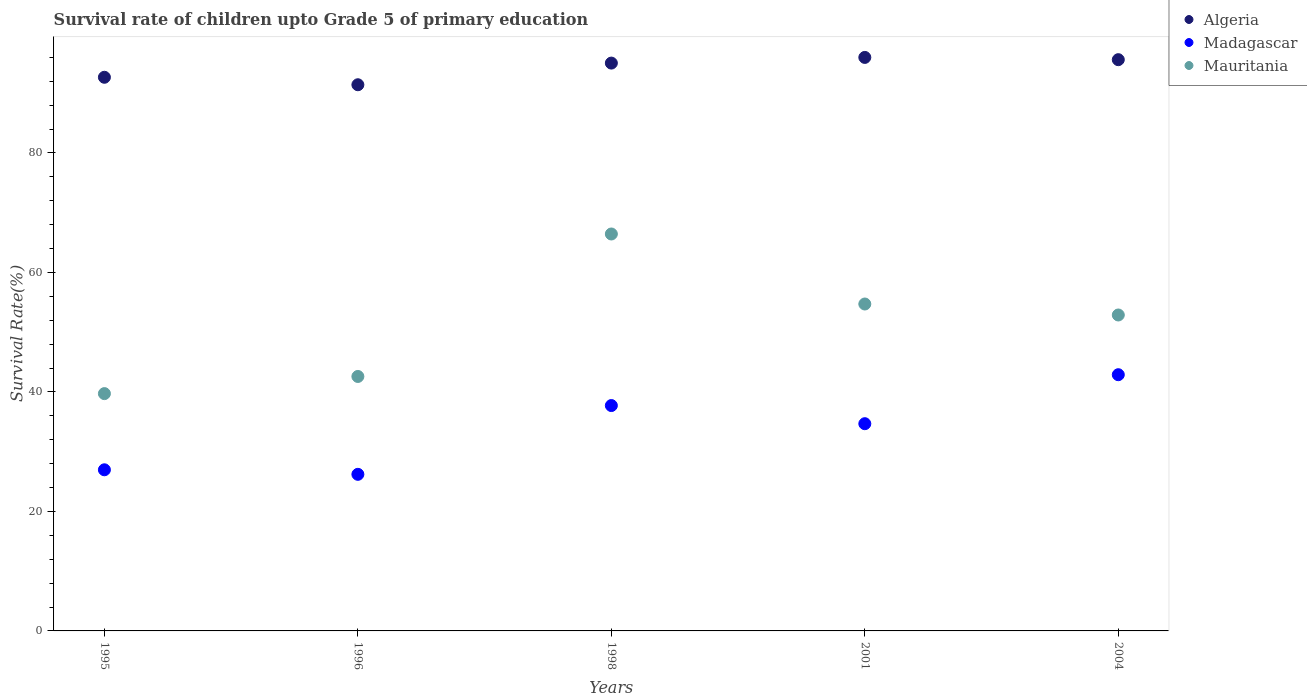What is the survival rate of children in Madagascar in 1995?
Give a very brief answer. 26.97. Across all years, what is the maximum survival rate of children in Madagascar?
Ensure brevity in your answer.  42.88. Across all years, what is the minimum survival rate of children in Algeria?
Make the answer very short. 91.41. In which year was the survival rate of children in Algeria maximum?
Offer a terse response. 2001. What is the total survival rate of children in Madagascar in the graph?
Provide a succinct answer. 168.46. What is the difference between the survival rate of children in Algeria in 1998 and that in 2004?
Give a very brief answer. -0.57. What is the difference between the survival rate of children in Madagascar in 2004 and the survival rate of children in Mauritania in 1995?
Provide a succinct answer. 3.17. What is the average survival rate of children in Madagascar per year?
Make the answer very short. 33.69. In the year 1996, what is the difference between the survival rate of children in Algeria and survival rate of children in Mauritania?
Keep it short and to the point. 48.82. What is the ratio of the survival rate of children in Mauritania in 1996 to that in 2001?
Offer a very short reply. 0.78. Is the survival rate of children in Mauritania in 1996 less than that in 2004?
Keep it short and to the point. Yes. What is the difference between the highest and the second highest survival rate of children in Mauritania?
Your response must be concise. 11.72. What is the difference between the highest and the lowest survival rate of children in Madagascar?
Your answer should be compact. 16.67. In how many years, is the survival rate of children in Madagascar greater than the average survival rate of children in Madagascar taken over all years?
Offer a very short reply. 3. Is the sum of the survival rate of children in Madagascar in 1998 and 2004 greater than the maximum survival rate of children in Mauritania across all years?
Offer a very short reply. Yes. Does the survival rate of children in Algeria monotonically increase over the years?
Provide a succinct answer. No. Is the survival rate of children in Madagascar strictly less than the survival rate of children in Algeria over the years?
Offer a terse response. Yes. What is the difference between two consecutive major ticks on the Y-axis?
Provide a short and direct response. 20. How many legend labels are there?
Offer a terse response. 3. What is the title of the graph?
Your answer should be very brief. Survival rate of children upto Grade 5 of primary education. Does "Cayman Islands" appear as one of the legend labels in the graph?
Offer a terse response. No. What is the label or title of the Y-axis?
Offer a very short reply. Survival Rate(%). What is the Survival Rate(%) of Algeria in 1995?
Provide a succinct answer. 92.66. What is the Survival Rate(%) of Madagascar in 1995?
Keep it short and to the point. 26.97. What is the Survival Rate(%) of Mauritania in 1995?
Your answer should be very brief. 39.72. What is the Survival Rate(%) in Algeria in 1996?
Give a very brief answer. 91.41. What is the Survival Rate(%) of Madagascar in 1996?
Make the answer very short. 26.21. What is the Survival Rate(%) in Mauritania in 1996?
Ensure brevity in your answer.  42.59. What is the Survival Rate(%) of Algeria in 1998?
Give a very brief answer. 95.04. What is the Survival Rate(%) of Madagascar in 1998?
Make the answer very short. 37.72. What is the Survival Rate(%) in Mauritania in 1998?
Give a very brief answer. 66.43. What is the Survival Rate(%) of Algeria in 2001?
Provide a short and direct response. 95.99. What is the Survival Rate(%) of Madagascar in 2001?
Your response must be concise. 34.68. What is the Survival Rate(%) in Mauritania in 2001?
Give a very brief answer. 54.71. What is the Survival Rate(%) in Algeria in 2004?
Ensure brevity in your answer.  95.61. What is the Survival Rate(%) of Madagascar in 2004?
Provide a succinct answer. 42.88. What is the Survival Rate(%) in Mauritania in 2004?
Offer a terse response. 52.88. Across all years, what is the maximum Survival Rate(%) in Algeria?
Make the answer very short. 95.99. Across all years, what is the maximum Survival Rate(%) in Madagascar?
Keep it short and to the point. 42.88. Across all years, what is the maximum Survival Rate(%) in Mauritania?
Keep it short and to the point. 66.43. Across all years, what is the minimum Survival Rate(%) in Algeria?
Your answer should be compact. 91.41. Across all years, what is the minimum Survival Rate(%) of Madagascar?
Your response must be concise. 26.21. Across all years, what is the minimum Survival Rate(%) of Mauritania?
Offer a very short reply. 39.72. What is the total Survival Rate(%) in Algeria in the graph?
Ensure brevity in your answer.  470.7. What is the total Survival Rate(%) of Madagascar in the graph?
Ensure brevity in your answer.  168.46. What is the total Survival Rate(%) of Mauritania in the graph?
Ensure brevity in your answer.  256.33. What is the difference between the Survival Rate(%) in Algeria in 1995 and that in 1996?
Offer a terse response. 1.25. What is the difference between the Survival Rate(%) of Madagascar in 1995 and that in 1996?
Your response must be concise. 0.76. What is the difference between the Survival Rate(%) of Mauritania in 1995 and that in 1996?
Provide a succinct answer. -2.87. What is the difference between the Survival Rate(%) in Algeria in 1995 and that in 1998?
Make the answer very short. -2.37. What is the difference between the Survival Rate(%) of Madagascar in 1995 and that in 1998?
Make the answer very short. -10.75. What is the difference between the Survival Rate(%) in Mauritania in 1995 and that in 1998?
Your answer should be compact. -26.72. What is the difference between the Survival Rate(%) in Algeria in 1995 and that in 2001?
Keep it short and to the point. -3.32. What is the difference between the Survival Rate(%) in Madagascar in 1995 and that in 2001?
Offer a terse response. -7.72. What is the difference between the Survival Rate(%) of Mauritania in 1995 and that in 2001?
Provide a short and direct response. -15. What is the difference between the Survival Rate(%) of Algeria in 1995 and that in 2004?
Your response must be concise. -2.95. What is the difference between the Survival Rate(%) in Madagascar in 1995 and that in 2004?
Your answer should be very brief. -15.91. What is the difference between the Survival Rate(%) in Mauritania in 1995 and that in 2004?
Provide a succinct answer. -13.16. What is the difference between the Survival Rate(%) in Algeria in 1996 and that in 1998?
Your response must be concise. -3.62. What is the difference between the Survival Rate(%) of Madagascar in 1996 and that in 1998?
Provide a succinct answer. -11.51. What is the difference between the Survival Rate(%) in Mauritania in 1996 and that in 1998?
Offer a very short reply. -23.85. What is the difference between the Survival Rate(%) of Algeria in 1996 and that in 2001?
Your answer should be very brief. -4.57. What is the difference between the Survival Rate(%) of Madagascar in 1996 and that in 2001?
Offer a terse response. -8.47. What is the difference between the Survival Rate(%) in Mauritania in 1996 and that in 2001?
Give a very brief answer. -12.13. What is the difference between the Survival Rate(%) in Algeria in 1996 and that in 2004?
Your answer should be compact. -4.2. What is the difference between the Survival Rate(%) in Madagascar in 1996 and that in 2004?
Ensure brevity in your answer.  -16.67. What is the difference between the Survival Rate(%) of Mauritania in 1996 and that in 2004?
Offer a very short reply. -10.29. What is the difference between the Survival Rate(%) in Algeria in 1998 and that in 2001?
Keep it short and to the point. -0.95. What is the difference between the Survival Rate(%) in Madagascar in 1998 and that in 2001?
Keep it short and to the point. 3.04. What is the difference between the Survival Rate(%) in Mauritania in 1998 and that in 2001?
Ensure brevity in your answer.  11.72. What is the difference between the Survival Rate(%) of Algeria in 1998 and that in 2004?
Provide a succinct answer. -0.57. What is the difference between the Survival Rate(%) in Madagascar in 1998 and that in 2004?
Ensure brevity in your answer.  -5.16. What is the difference between the Survival Rate(%) in Mauritania in 1998 and that in 2004?
Your response must be concise. 13.56. What is the difference between the Survival Rate(%) in Algeria in 2001 and that in 2004?
Provide a succinct answer. 0.38. What is the difference between the Survival Rate(%) in Madagascar in 2001 and that in 2004?
Your response must be concise. -8.2. What is the difference between the Survival Rate(%) of Mauritania in 2001 and that in 2004?
Make the answer very short. 1.84. What is the difference between the Survival Rate(%) of Algeria in 1995 and the Survival Rate(%) of Madagascar in 1996?
Your response must be concise. 66.45. What is the difference between the Survival Rate(%) of Algeria in 1995 and the Survival Rate(%) of Mauritania in 1996?
Give a very brief answer. 50.07. What is the difference between the Survival Rate(%) in Madagascar in 1995 and the Survival Rate(%) in Mauritania in 1996?
Offer a very short reply. -15.62. What is the difference between the Survival Rate(%) in Algeria in 1995 and the Survival Rate(%) in Madagascar in 1998?
Make the answer very short. 54.94. What is the difference between the Survival Rate(%) of Algeria in 1995 and the Survival Rate(%) of Mauritania in 1998?
Provide a short and direct response. 26.23. What is the difference between the Survival Rate(%) in Madagascar in 1995 and the Survival Rate(%) in Mauritania in 1998?
Your answer should be very brief. -39.47. What is the difference between the Survival Rate(%) in Algeria in 1995 and the Survival Rate(%) in Madagascar in 2001?
Make the answer very short. 57.98. What is the difference between the Survival Rate(%) in Algeria in 1995 and the Survival Rate(%) in Mauritania in 2001?
Provide a short and direct response. 37.95. What is the difference between the Survival Rate(%) of Madagascar in 1995 and the Survival Rate(%) of Mauritania in 2001?
Offer a very short reply. -27.75. What is the difference between the Survival Rate(%) in Algeria in 1995 and the Survival Rate(%) in Madagascar in 2004?
Your answer should be very brief. 49.78. What is the difference between the Survival Rate(%) of Algeria in 1995 and the Survival Rate(%) of Mauritania in 2004?
Provide a short and direct response. 39.78. What is the difference between the Survival Rate(%) of Madagascar in 1995 and the Survival Rate(%) of Mauritania in 2004?
Your answer should be compact. -25.91. What is the difference between the Survival Rate(%) of Algeria in 1996 and the Survival Rate(%) of Madagascar in 1998?
Give a very brief answer. 53.69. What is the difference between the Survival Rate(%) of Algeria in 1996 and the Survival Rate(%) of Mauritania in 1998?
Keep it short and to the point. 24.98. What is the difference between the Survival Rate(%) of Madagascar in 1996 and the Survival Rate(%) of Mauritania in 1998?
Provide a succinct answer. -40.22. What is the difference between the Survival Rate(%) of Algeria in 1996 and the Survival Rate(%) of Madagascar in 2001?
Make the answer very short. 56.73. What is the difference between the Survival Rate(%) in Algeria in 1996 and the Survival Rate(%) in Mauritania in 2001?
Give a very brief answer. 36.7. What is the difference between the Survival Rate(%) in Madagascar in 1996 and the Survival Rate(%) in Mauritania in 2001?
Your answer should be very brief. -28.51. What is the difference between the Survival Rate(%) of Algeria in 1996 and the Survival Rate(%) of Madagascar in 2004?
Make the answer very short. 48.53. What is the difference between the Survival Rate(%) of Algeria in 1996 and the Survival Rate(%) of Mauritania in 2004?
Your answer should be very brief. 38.53. What is the difference between the Survival Rate(%) in Madagascar in 1996 and the Survival Rate(%) in Mauritania in 2004?
Offer a terse response. -26.67. What is the difference between the Survival Rate(%) of Algeria in 1998 and the Survival Rate(%) of Madagascar in 2001?
Keep it short and to the point. 60.35. What is the difference between the Survival Rate(%) in Algeria in 1998 and the Survival Rate(%) in Mauritania in 2001?
Provide a short and direct response. 40.32. What is the difference between the Survival Rate(%) of Madagascar in 1998 and the Survival Rate(%) of Mauritania in 2001?
Keep it short and to the point. -16.99. What is the difference between the Survival Rate(%) in Algeria in 1998 and the Survival Rate(%) in Madagascar in 2004?
Ensure brevity in your answer.  52.15. What is the difference between the Survival Rate(%) in Algeria in 1998 and the Survival Rate(%) in Mauritania in 2004?
Give a very brief answer. 42.16. What is the difference between the Survival Rate(%) of Madagascar in 1998 and the Survival Rate(%) of Mauritania in 2004?
Your response must be concise. -15.16. What is the difference between the Survival Rate(%) in Algeria in 2001 and the Survival Rate(%) in Madagascar in 2004?
Ensure brevity in your answer.  53.1. What is the difference between the Survival Rate(%) in Algeria in 2001 and the Survival Rate(%) in Mauritania in 2004?
Your answer should be compact. 43.11. What is the difference between the Survival Rate(%) in Madagascar in 2001 and the Survival Rate(%) in Mauritania in 2004?
Keep it short and to the point. -18.19. What is the average Survival Rate(%) in Algeria per year?
Keep it short and to the point. 94.14. What is the average Survival Rate(%) in Madagascar per year?
Offer a very short reply. 33.69. What is the average Survival Rate(%) in Mauritania per year?
Give a very brief answer. 51.27. In the year 1995, what is the difference between the Survival Rate(%) in Algeria and Survival Rate(%) in Madagascar?
Your answer should be very brief. 65.69. In the year 1995, what is the difference between the Survival Rate(%) in Algeria and Survival Rate(%) in Mauritania?
Give a very brief answer. 52.94. In the year 1995, what is the difference between the Survival Rate(%) in Madagascar and Survival Rate(%) in Mauritania?
Offer a very short reply. -12.75. In the year 1996, what is the difference between the Survival Rate(%) of Algeria and Survival Rate(%) of Madagascar?
Ensure brevity in your answer.  65.2. In the year 1996, what is the difference between the Survival Rate(%) of Algeria and Survival Rate(%) of Mauritania?
Your answer should be compact. 48.82. In the year 1996, what is the difference between the Survival Rate(%) of Madagascar and Survival Rate(%) of Mauritania?
Your response must be concise. -16.38. In the year 1998, what is the difference between the Survival Rate(%) in Algeria and Survival Rate(%) in Madagascar?
Your answer should be very brief. 57.32. In the year 1998, what is the difference between the Survival Rate(%) of Algeria and Survival Rate(%) of Mauritania?
Provide a succinct answer. 28.6. In the year 1998, what is the difference between the Survival Rate(%) in Madagascar and Survival Rate(%) in Mauritania?
Your answer should be compact. -28.71. In the year 2001, what is the difference between the Survival Rate(%) in Algeria and Survival Rate(%) in Madagascar?
Your answer should be very brief. 61.3. In the year 2001, what is the difference between the Survival Rate(%) of Algeria and Survival Rate(%) of Mauritania?
Keep it short and to the point. 41.27. In the year 2001, what is the difference between the Survival Rate(%) of Madagascar and Survival Rate(%) of Mauritania?
Offer a very short reply. -20.03. In the year 2004, what is the difference between the Survival Rate(%) of Algeria and Survival Rate(%) of Madagascar?
Provide a short and direct response. 52.73. In the year 2004, what is the difference between the Survival Rate(%) of Algeria and Survival Rate(%) of Mauritania?
Ensure brevity in your answer.  42.73. In the year 2004, what is the difference between the Survival Rate(%) in Madagascar and Survival Rate(%) in Mauritania?
Your response must be concise. -10. What is the ratio of the Survival Rate(%) in Algeria in 1995 to that in 1996?
Provide a succinct answer. 1.01. What is the ratio of the Survival Rate(%) in Madagascar in 1995 to that in 1996?
Provide a short and direct response. 1.03. What is the ratio of the Survival Rate(%) in Mauritania in 1995 to that in 1996?
Offer a terse response. 0.93. What is the ratio of the Survival Rate(%) in Algeria in 1995 to that in 1998?
Your answer should be compact. 0.97. What is the ratio of the Survival Rate(%) of Madagascar in 1995 to that in 1998?
Your answer should be compact. 0.71. What is the ratio of the Survival Rate(%) in Mauritania in 1995 to that in 1998?
Keep it short and to the point. 0.6. What is the ratio of the Survival Rate(%) of Algeria in 1995 to that in 2001?
Your answer should be compact. 0.97. What is the ratio of the Survival Rate(%) of Madagascar in 1995 to that in 2001?
Make the answer very short. 0.78. What is the ratio of the Survival Rate(%) of Mauritania in 1995 to that in 2001?
Offer a terse response. 0.73. What is the ratio of the Survival Rate(%) of Algeria in 1995 to that in 2004?
Ensure brevity in your answer.  0.97. What is the ratio of the Survival Rate(%) in Madagascar in 1995 to that in 2004?
Your answer should be compact. 0.63. What is the ratio of the Survival Rate(%) in Mauritania in 1995 to that in 2004?
Your response must be concise. 0.75. What is the ratio of the Survival Rate(%) in Algeria in 1996 to that in 1998?
Give a very brief answer. 0.96. What is the ratio of the Survival Rate(%) in Madagascar in 1996 to that in 1998?
Your answer should be very brief. 0.69. What is the ratio of the Survival Rate(%) of Mauritania in 1996 to that in 1998?
Your answer should be compact. 0.64. What is the ratio of the Survival Rate(%) in Algeria in 1996 to that in 2001?
Your answer should be compact. 0.95. What is the ratio of the Survival Rate(%) in Madagascar in 1996 to that in 2001?
Give a very brief answer. 0.76. What is the ratio of the Survival Rate(%) of Mauritania in 1996 to that in 2001?
Provide a succinct answer. 0.78. What is the ratio of the Survival Rate(%) of Algeria in 1996 to that in 2004?
Your response must be concise. 0.96. What is the ratio of the Survival Rate(%) of Madagascar in 1996 to that in 2004?
Provide a short and direct response. 0.61. What is the ratio of the Survival Rate(%) in Mauritania in 1996 to that in 2004?
Make the answer very short. 0.81. What is the ratio of the Survival Rate(%) in Algeria in 1998 to that in 2001?
Your answer should be compact. 0.99. What is the ratio of the Survival Rate(%) in Madagascar in 1998 to that in 2001?
Ensure brevity in your answer.  1.09. What is the ratio of the Survival Rate(%) in Mauritania in 1998 to that in 2001?
Your answer should be very brief. 1.21. What is the ratio of the Survival Rate(%) in Madagascar in 1998 to that in 2004?
Keep it short and to the point. 0.88. What is the ratio of the Survival Rate(%) in Mauritania in 1998 to that in 2004?
Your response must be concise. 1.26. What is the ratio of the Survival Rate(%) of Algeria in 2001 to that in 2004?
Your answer should be compact. 1. What is the ratio of the Survival Rate(%) in Madagascar in 2001 to that in 2004?
Your answer should be compact. 0.81. What is the ratio of the Survival Rate(%) of Mauritania in 2001 to that in 2004?
Offer a terse response. 1.03. What is the difference between the highest and the second highest Survival Rate(%) in Algeria?
Your answer should be very brief. 0.38. What is the difference between the highest and the second highest Survival Rate(%) in Madagascar?
Give a very brief answer. 5.16. What is the difference between the highest and the second highest Survival Rate(%) of Mauritania?
Provide a short and direct response. 11.72. What is the difference between the highest and the lowest Survival Rate(%) in Algeria?
Give a very brief answer. 4.57. What is the difference between the highest and the lowest Survival Rate(%) in Madagascar?
Your response must be concise. 16.67. What is the difference between the highest and the lowest Survival Rate(%) in Mauritania?
Your answer should be very brief. 26.72. 